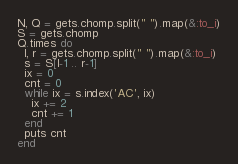Convert code to text. <code><loc_0><loc_0><loc_500><loc_500><_Ruby_>
N, Q = gets.chomp.split(" ").map(&:to_i)
S = gets.chomp
Q.times do
  l, r = gets.chomp.split(" ").map(&:to_i)
  s = S[l-1 .. r-1]
  ix = 0
  cnt = 0
  while ix = s.index('AC', ix)
    ix += 2
    cnt += 1
  end
  puts cnt
end
</code> 